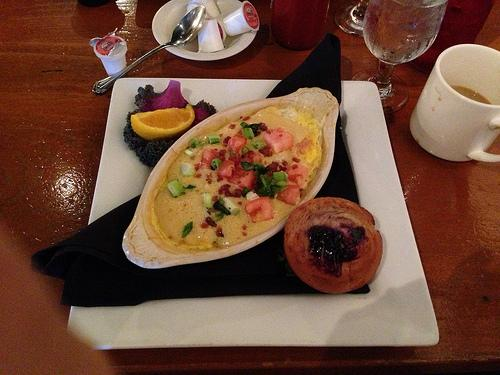Explain the appearance of the folded black cloth napkin in the image. The black cloth napkin is folded into a triangle and placed under the oval dish containing the main dish. What kind of fruit can be seen in the image and where is it placed? A slice of orange and lemon wedge can be seen, placed next to the main dish and atop the garnish. List the cutlery items on the table and describe their appearance. There is a silver spoon and a stainless steel teaspoon on the table, both appearing shiny and clean. Identify the main dish served in the image and its ingredients. The main dish is a cheesy entree served on a white square plate, containing green onions, tomato, red topping, and a lemon garnish. What ingredients can be spotted in the pastry with jam? The pastry has blackberry jam and appears to be made of brown bread. Describe the beverage that is present in the image and the container it is in. The beverage present is coffee, which is in a white mug with a handle. Describe the condition and contents of the glass and cup in the image. The glass has condensation and contains cold water, while the cup contains coffee and looks white and clean. What objects can be seen on the wooden table in the image? On the wooden table, there is a meal served on a white square plate, a cold glass of water, a coffee cup holding a beverage, a dish with creamers, a silver spoon, and a black cloth napkin folded into a triangle. Explain the arrangement of food in the dish and the napkin under it. The dish contains a cheesy entree with green onions, tomato, and red topping, placed on a black cloth napkin folded into a triangle. Is the dog sitting patiently under the wooden table waiting for a treat? There is no mention of a dog in the image information provided. This instruction is misleading because it forms a question about a non-existent object and implies a narrative that does not exist in the scene. There is a small green potted plant in the background, behind the cold glass of water. There is no mention of a potted plant in the image information provided. This instruction is misleading because it uses a declarative sentence to describe an object that is not present in the scene, causing the user to search for something that doesn't exist. Can you spot the pink umbrella resting on the wooden table?  There is no mention of a pink umbrella in the image information provided. This instruction is misleading because it asks the user to search for a non-existent object and uses interrogative language to prompt curiosity. The chef's hat can be seen hanging on the chair beside the wooden table. There is no mention of a chef's hat or a chair in the image information provided. This instruction is misleading because it introduces new objects that do not exist in the scene through a declarative sentence. Observe the delicate pink flower in the vase next to the meal served on the white square plate. There is no mention of a flower or vase in the image information provided. This instruction is misleading because it provides a false statement using a declarative sentence, describing an object that does not exist in the scene. Can you find the blue-striped napkin resting on the edge of the oval dish with creamy food? There is no mention of a blue-striped napkin in the image information provided. This instruction is misleading because it uses an interrogative sentence to ask the user to search for a non-existent object, adding confusion to the scene. 